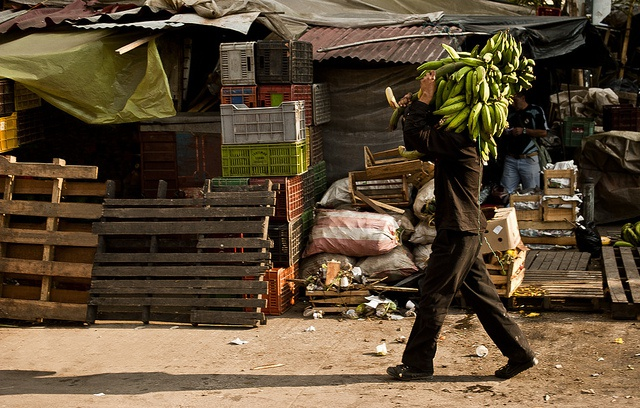Describe the objects in this image and their specific colors. I can see people in black, maroon, and gray tones, people in black, gray, and maroon tones, banana in black, olive, and khaki tones, banana in black, olive, and khaki tones, and banana in black and olive tones in this image. 